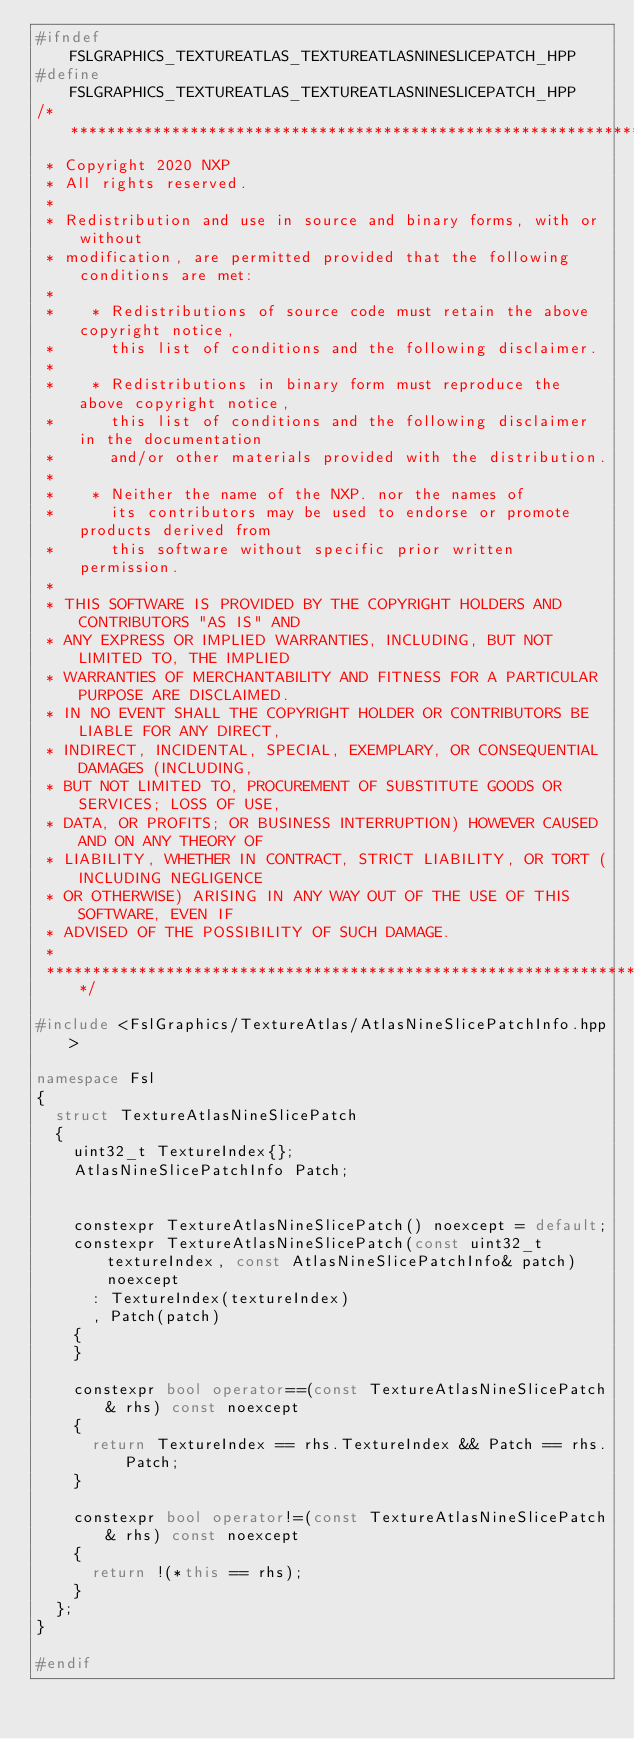Convert code to text. <code><loc_0><loc_0><loc_500><loc_500><_C++_>#ifndef FSLGRAPHICS_TEXTUREATLAS_TEXTUREATLASNINESLICEPATCH_HPP
#define FSLGRAPHICS_TEXTUREATLAS_TEXTUREATLASNINESLICEPATCH_HPP
/****************************************************************************************************************************************************
 * Copyright 2020 NXP
 * All rights reserved.
 *
 * Redistribution and use in source and binary forms, with or without
 * modification, are permitted provided that the following conditions are met:
 *
 *    * Redistributions of source code must retain the above copyright notice,
 *      this list of conditions and the following disclaimer.
 *
 *    * Redistributions in binary form must reproduce the above copyright notice,
 *      this list of conditions and the following disclaimer in the documentation
 *      and/or other materials provided with the distribution.
 *
 *    * Neither the name of the NXP. nor the names of
 *      its contributors may be used to endorse or promote products derived from
 *      this software without specific prior written permission.
 *
 * THIS SOFTWARE IS PROVIDED BY THE COPYRIGHT HOLDERS AND CONTRIBUTORS "AS IS" AND
 * ANY EXPRESS OR IMPLIED WARRANTIES, INCLUDING, BUT NOT LIMITED TO, THE IMPLIED
 * WARRANTIES OF MERCHANTABILITY AND FITNESS FOR A PARTICULAR PURPOSE ARE DISCLAIMED.
 * IN NO EVENT SHALL THE COPYRIGHT HOLDER OR CONTRIBUTORS BE LIABLE FOR ANY DIRECT,
 * INDIRECT, INCIDENTAL, SPECIAL, EXEMPLARY, OR CONSEQUENTIAL DAMAGES (INCLUDING,
 * BUT NOT LIMITED TO, PROCUREMENT OF SUBSTITUTE GOODS OR SERVICES; LOSS OF USE,
 * DATA, OR PROFITS; OR BUSINESS INTERRUPTION) HOWEVER CAUSED AND ON ANY THEORY OF
 * LIABILITY, WHETHER IN CONTRACT, STRICT LIABILITY, OR TORT (INCLUDING NEGLIGENCE
 * OR OTHERWISE) ARISING IN ANY WAY OUT OF THE USE OF THIS SOFTWARE, EVEN IF
 * ADVISED OF THE POSSIBILITY OF SUCH DAMAGE.
 *
 ****************************************************************************************************************************************************/

#include <FslGraphics/TextureAtlas/AtlasNineSlicePatchInfo.hpp>

namespace Fsl
{
  struct TextureAtlasNineSlicePatch
  {
    uint32_t TextureIndex{};
    AtlasNineSlicePatchInfo Patch;


    constexpr TextureAtlasNineSlicePatch() noexcept = default;
    constexpr TextureAtlasNineSlicePatch(const uint32_t textureIndex, const AtlasNineSlicePatchInfo& patch) noexcept
      : TextureIndex(textureIndex)
      , Patch(patch)
    {
    }

    constexpr bool operator==(const TextureAtlasNineSlicePatch& rhs) const noexcept
    {
      return TextureIndex == rhs.TextureIndex && Patch == rhs.Patch;
    }

    constexpr bool operator!=(const TextureAtlasNineSlicePatch& rhs) const noexcept
    {
      return !(*this == rhs);
    }
  };
}

#endif
</code> 